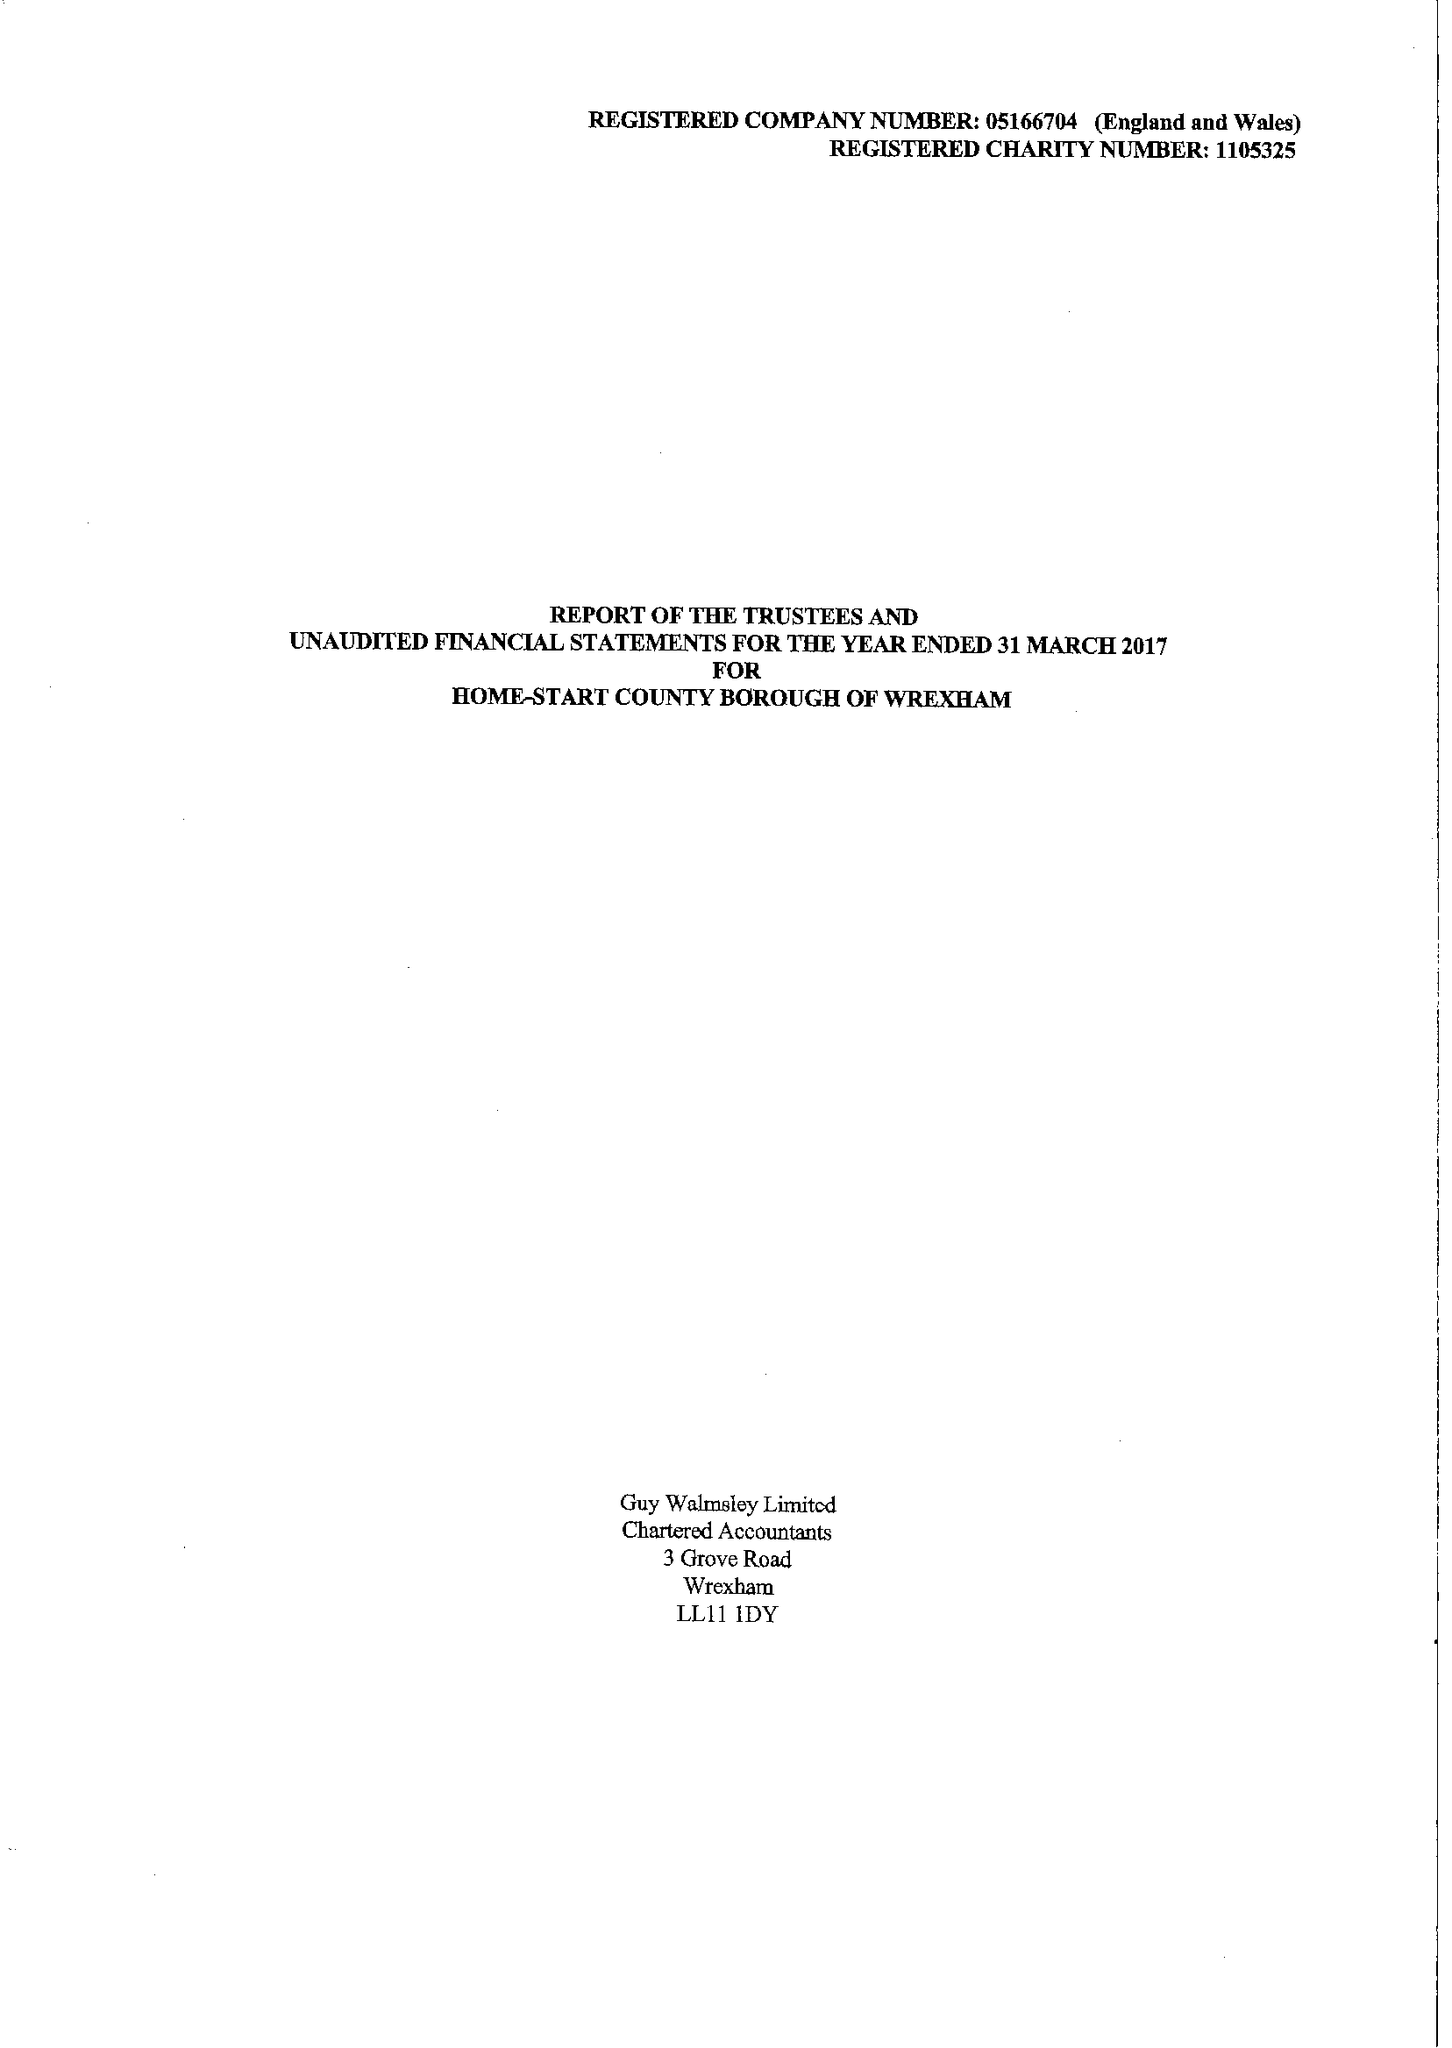What is the value for the address__post_town?
Answer the question using a single word or phrase. WREXHAM 